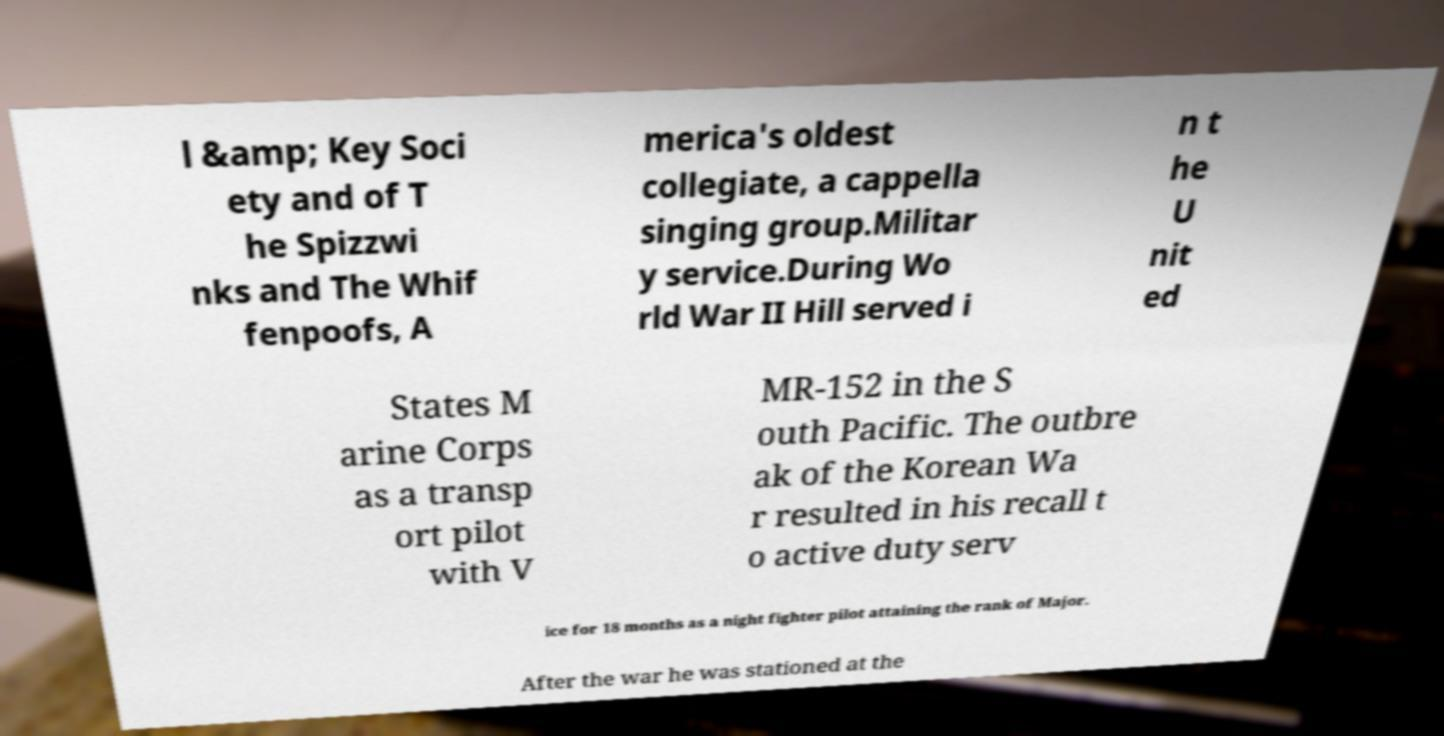Can you accurately transcribe the text from the provided image for me? l &amp; Key Soci ety and of T he Spizzwi nks and The Whif fenpoofs, A merica's oldest collegiate, a cappella singing group.Militar y service.During Wo rld War II Hill served i n t he U nit ed States M arine Corps as a transp ort pilot with V MR-152 in the S outh Pacific. The outbre ak of the Korean Wa r resulted in his recall t o active duty serv ice for 18 months as a night fighter pilot attaining the rank of Major. After the war he was stationed at the 